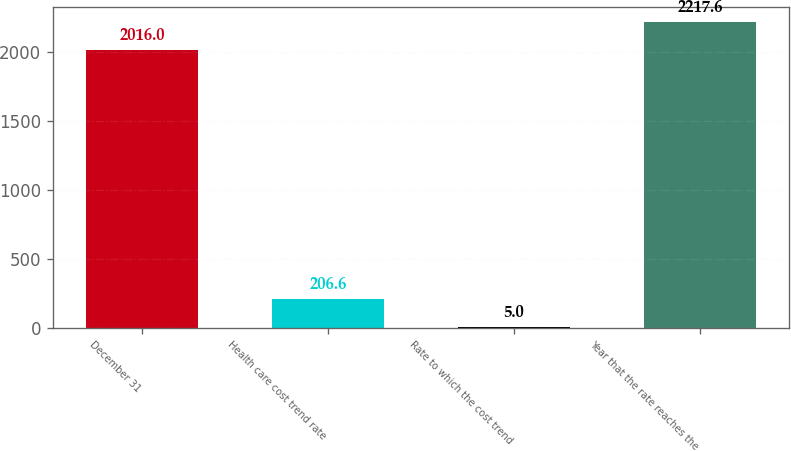<chart> <loc_0><loc_0><loc_500><loc_500><bar_chart><fcel>December 31<fcel>Health care cost trend rate<fcel>Rate to which the cost trend<fcel>Year that the rate reaches the<nl><fcel>2016<fcel>206.6<fcel>5<fcel>2217.6<nl></chart> 